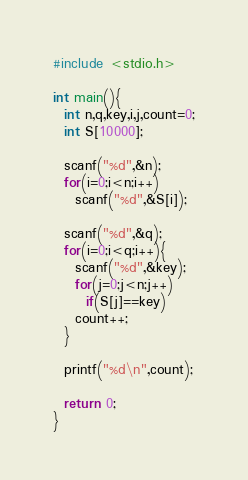Convert code to text. <code><loc_0><loc_0><loc_500><loc_500><_C_>#include <stdio.h>

int main(){
  int n,q,key,i,j,count=0;
  int S[10000];

  scanf("%d",&n);
  for(i=0;i<n;i++)
    scanf("%d",&S[i]);

  scanf("%d",&q);
  for(i=0;i<q;i++){
    scanf("%d",&key);
    for(j=0;j<n;j++)
      if(S[j]==key)
	count++;
  }

  printf("%d\n",count);

  return 0;
}</code> 